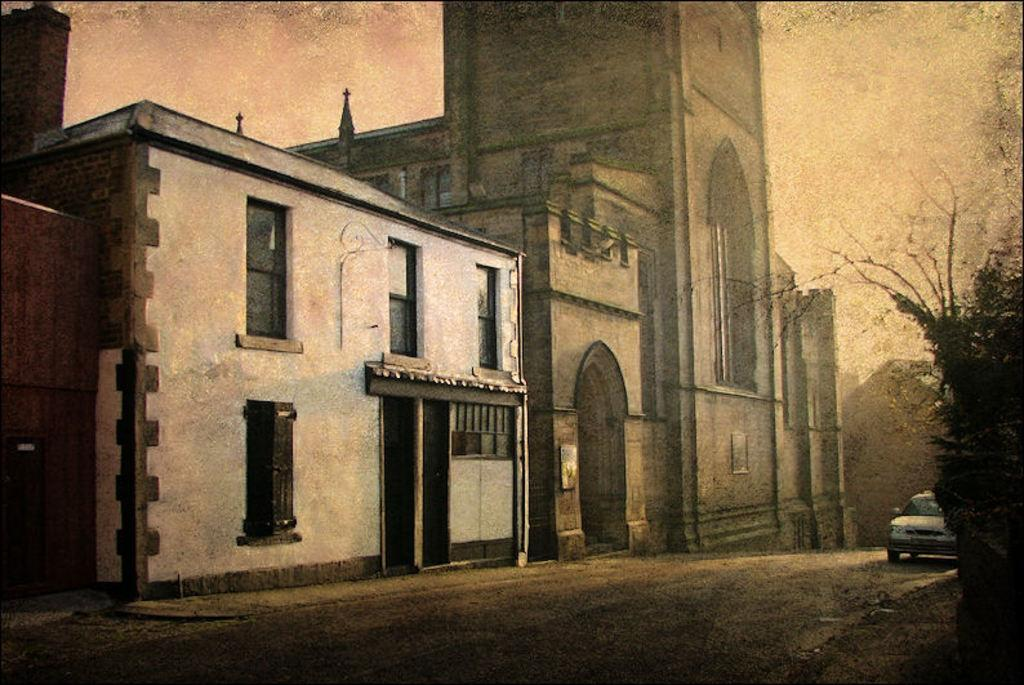What is the main subject of the image? There is a car on the road in the image. What else can be seen in the background of the image? There are buildings visible in the image. Is there any vegetation present in the image? Yes, there is a plant on the right side of the image. What type of writing can be seen on the car in the image? There is no writing visible on the car in the image. How many apples are hanging from the plant on the right side of the image? There are no apples present in the image; it features a plant without any visible fruit. 